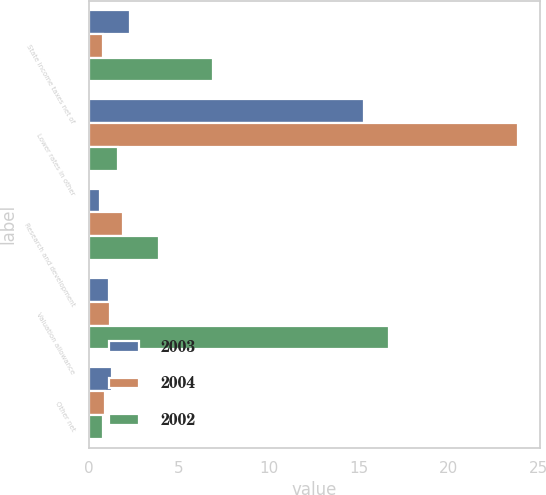Convert chart to OTSL. <chart><loc_0><loc_0><loc_500><loc_500><stacked_bar_chart><ecel><fcel>State income taxes net of<fcel>Lower rates in other<fcel>Research and development<fcel>Valuation allowance<fcel>Other net<nl><fcel>2003<fcel>2.3<fcel>15.3<fcel>0.6<fcel>1.1<fcel>1.3<nl><fcel>2004<fcel>0.8<fcel>23.9<fcel>1.9<fcel>1.2<fcel>0.9<nl><fcel>2002<fcel>6.9<fcel>1.6<fcel>3.9<fcel>16.7<fcel>0.8<nl></chart> 